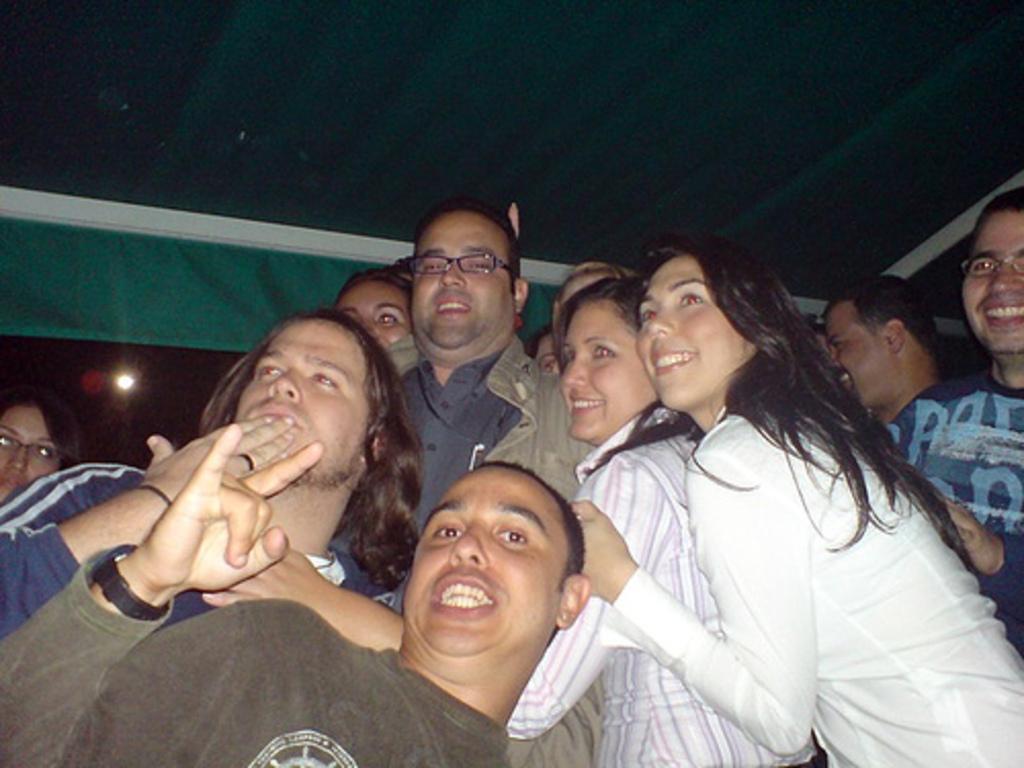Can you describe this image briefly? This picture shows a group of people standing with a smile on their faces and we see couple of men and a woman wore spectacles on their faces and we see a light. 